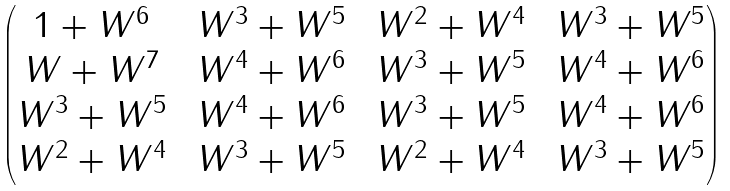Convert formula to latex. <formula><loc_0><loc_0><loc_500><loc_500>\begin{pmatrix} 1 + W ^ { 6 } \, & \, W ^ { 3 } + W ^ { 5 } \, & \, W ^ { 2 } + W ^ { 4 } \, & \, W ^ { 3 } + W ^ { 5 } \\ W + W ^ { 7 } \, & \, W ^ { 4 } + W ^ { 6 } \, & \, W ^ { 3 } + W ^ { 5 } \, & \, W ^ { 4 } + W ^ { 6 } \\ W ^ { 3 } + W ^ { 5 } \, & \, W ^ { 4 } + W ^ { 6 } \, & \, W ^ { 3 } + W ^ { 5 } \, & \, W ^ { 4 } + W ^ { 6 } \\ W ^ { 2 } + W ^ { 4 } \, & \, W ^ { 3 } + W ^ { 5 } \, & \, W ^ { 2 } + W ^ { 4 } \, & \, W ^ { 3 } + W ^ { 5 } \end{pmatrix}</formula> 